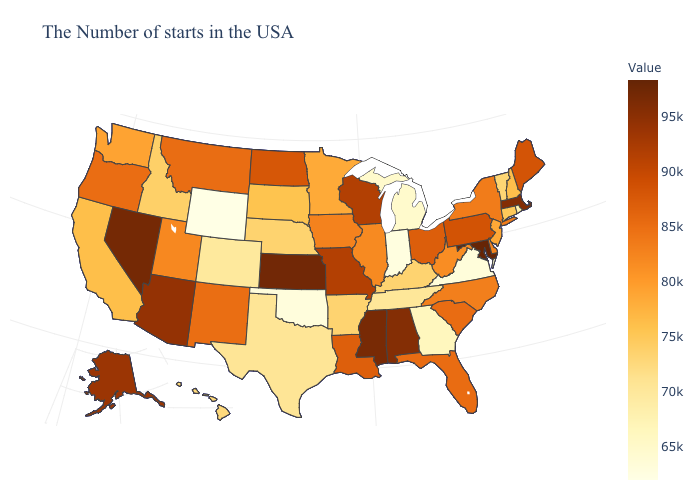Does Maryland have the highest value in the USA?
Quick response, please. Yes. Which states have the lowest value in the Northeast?
Be succinct. Rhode Island. Does Wyoming have the lowest value in the West?
Concise answer only. Yes. 